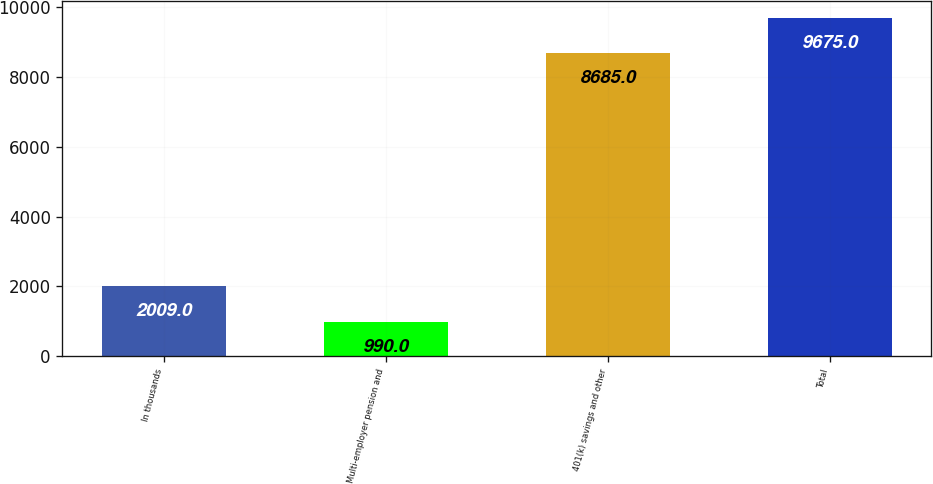Convert chart to OTSL. <chart><loc_0><loc_0><loc_500><loc_500><bar_chart><fcel>In thousands<fcel>Multi-employer pension and<fcel>401(k) savings and other<fcel>Total<nl><fcel>2009<fcel>990<fcel>8685<fcel>9675<nl></chart> 